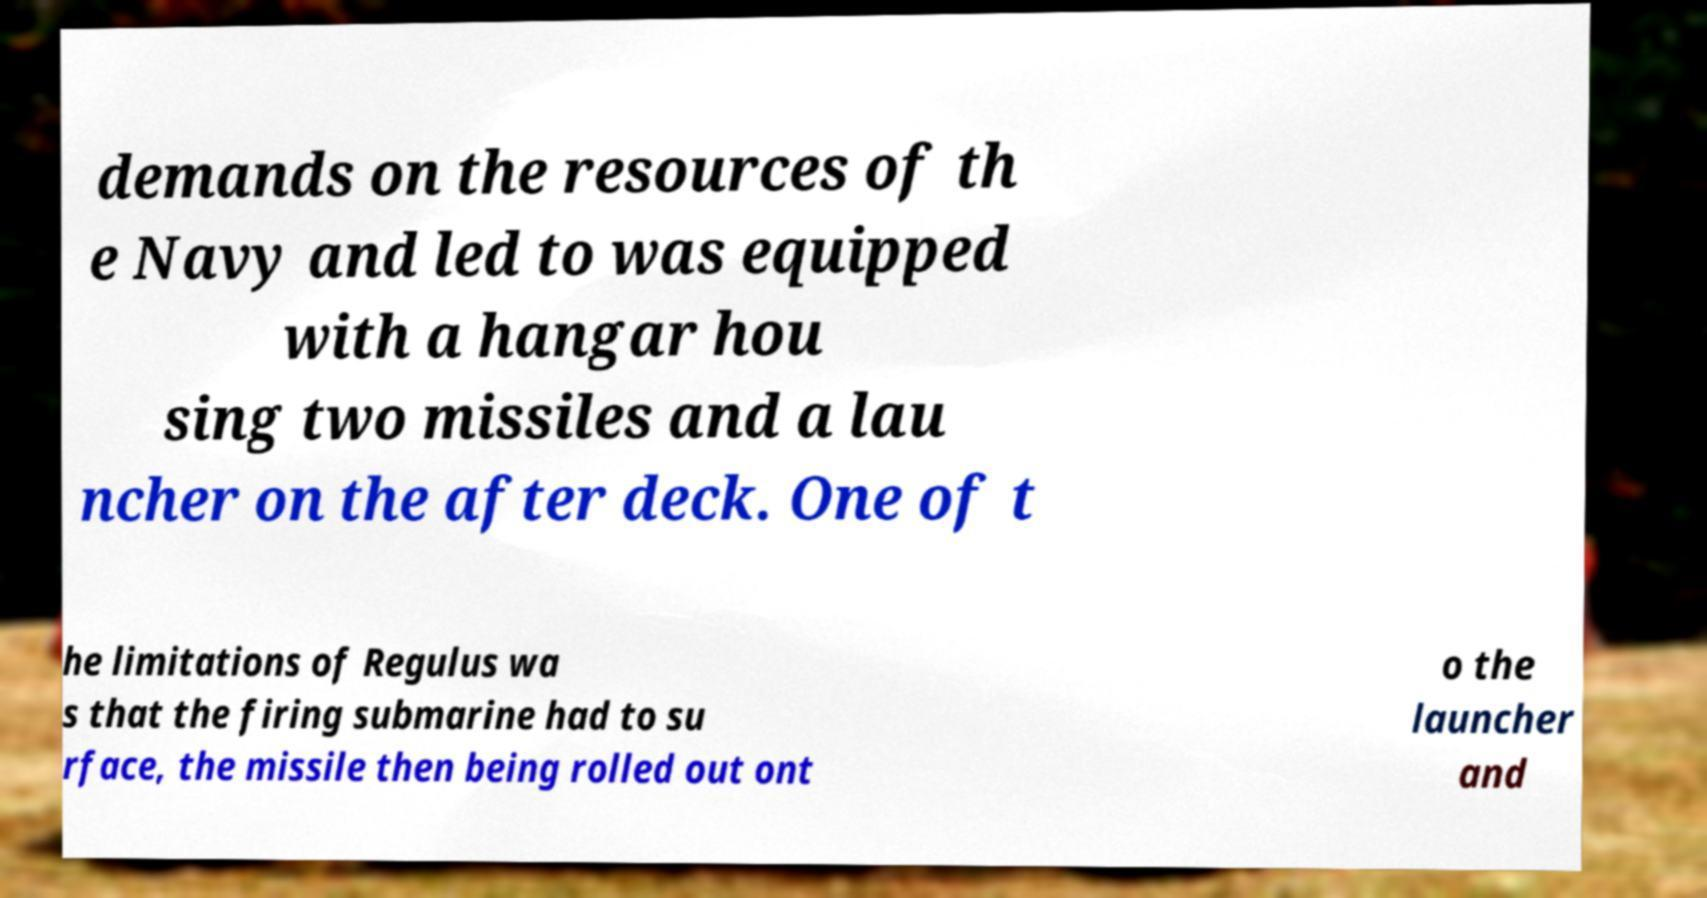Can you accurately transcribe the text from the provided image for me? demands on the resources of th e Navy and led to was equipped with a hangar hou sing two missiles and a lau ncher on the after deck. One of t he limitations of Regulus wa s that the firing submarine had to su rface, the missile then being rolled out ont o the launcher and 